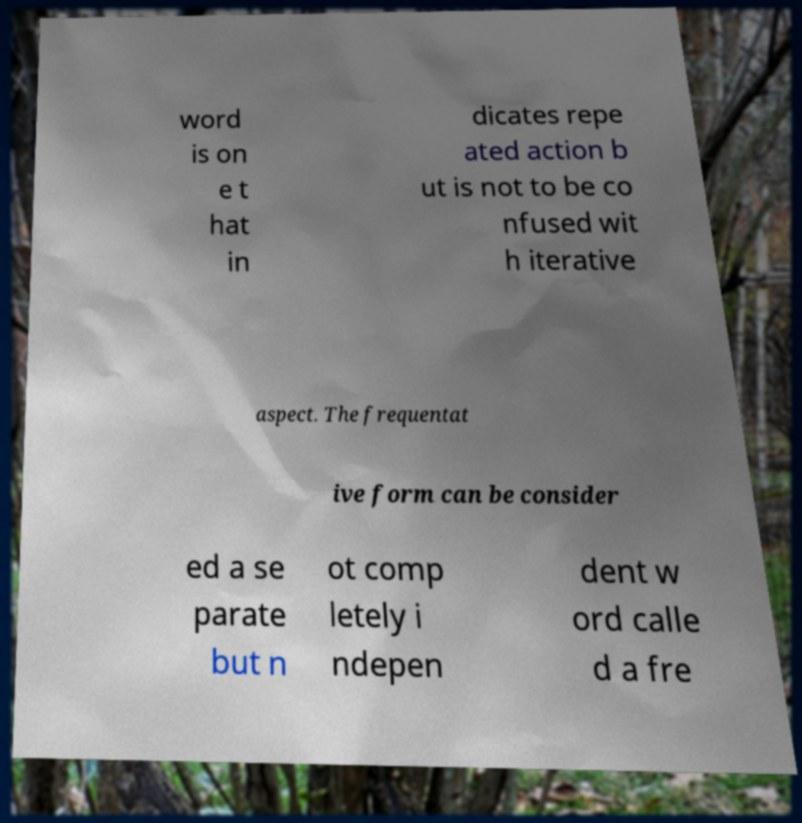Could you extract and type out the text from this image? word is on e t hat in dicates repe ated action b ut is not to be co nfused wit h iterative aspect. The frequentat ive form can be consider ed a se parate but n ot comp letely i ndepen dent w ord calle d a fre 